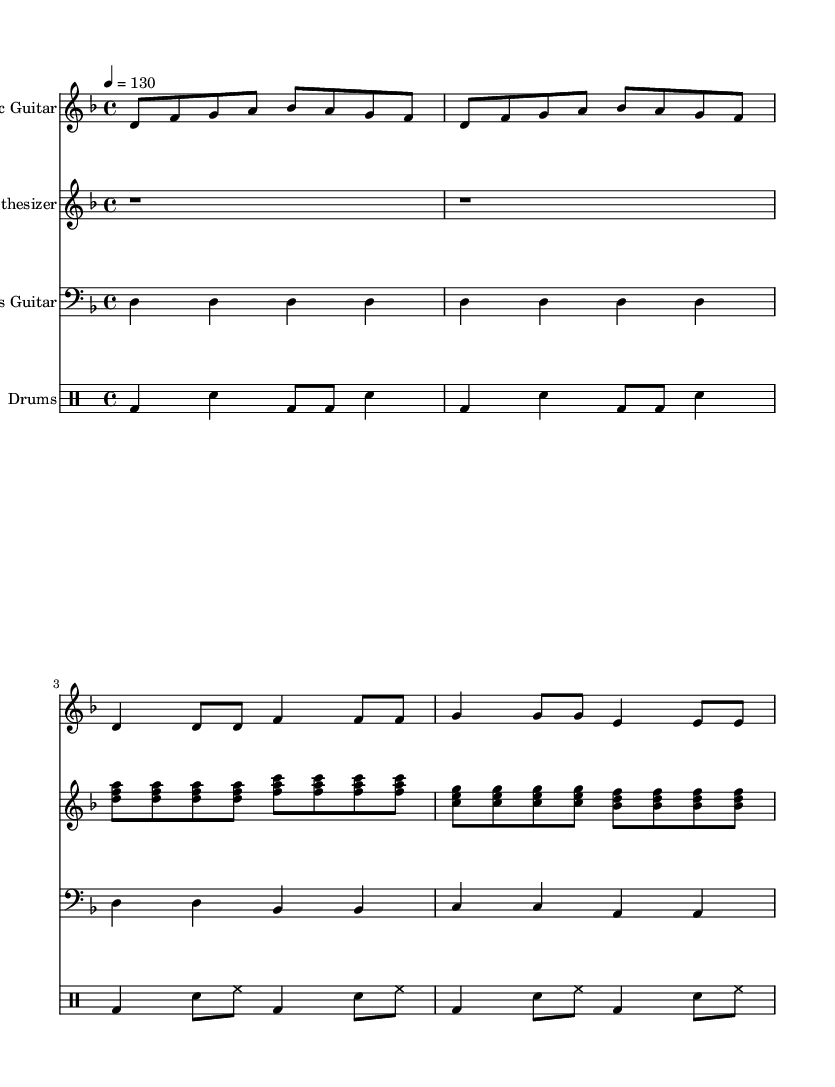What is the key signature of this music? The key signature is D minor, indicated by one flat (B♭) in the key signature box at the beginning of the score.
Answer: D minor What is the time signature of this music? The time signature is 4/4, shown at the beginning of the score next to the key signature, indicating four beats per measure.
Answer: 4/4 What is the tempo marking of this music? The tempo marking is 130 beats per minute, given by the '4 = 130' notation, which indicates the quarter note gets the beat at 130 BPM.
Answer: 130 How many measures are there in the Electric Guitar part? There are eight measures in the Electric Guitar part, counted by the bar lines in the staff.
Answer: 8 What is the lowest note in the Bass Guitar part? The lowest note in the Bass Guitar part is D, the first note in the part, shown at the start of the staff.
Answer: D Which instrument has a single rest at the beginning? The Synthesizer has a single rest at the beginning, indicated by the 'r1' notation, which means a whole rest.
Answer: Synthesizer How many different chord shapes are played in the Synthesizer part? There are four different chord shapes played in the Synthesizer part, identified by the chord symbols indicated in the staff (D minor, F major, C major, and B♭ major).
Answer: 4 